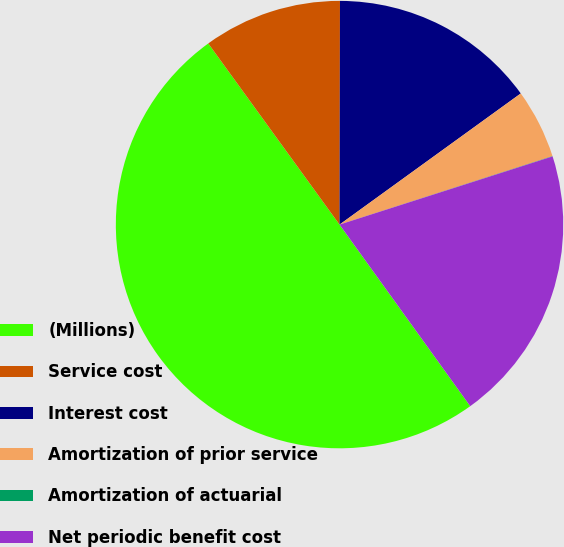Convert chart. <chart><loc_0><loc_0><loc_500><loc_500><pie_chart><fcel>(Millions)<fcel>Service cost<fcel>Interest cost<fcel>Amortization of prior service<fcel>Amortization of actuarial<fcel>Net periodic benefit cost<nl><fcel>49.95%<fcel>10.01%<fcel>15.0%<fcel>5.02%<fcel>0.02%<fcel>20.0%<nl></chart> 